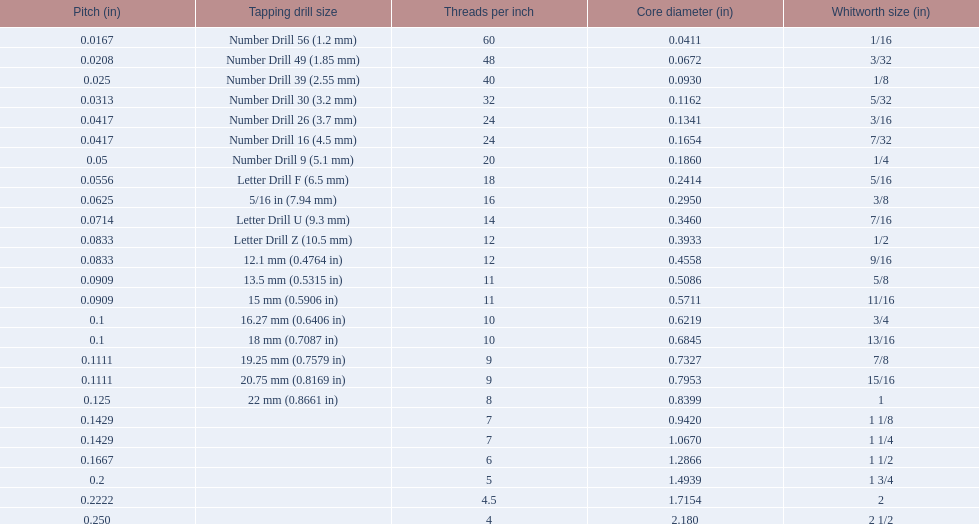What is the core diameter for the number drill 26? 0.1341. What is the whitworth size (in) for this core diameter? 3/16. 